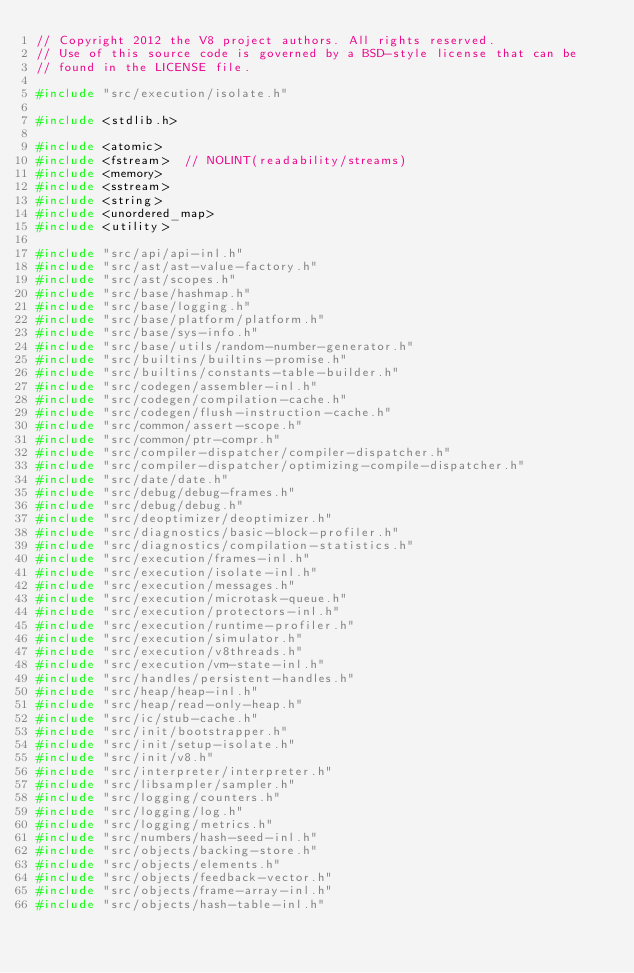<code> <loc_0><loc_0><loc_500><loc_500><_C++_>// Copyright 2012 the V8 project authors. All rights reserved.
// Use of this source code is governed by a BSD-style license that can be
// found in the LICENSE file.

#include "src/execution/isolate.h"

#include <stdlib.h>

#include <atomic>
#include <fstream>  // NOLINT(readability/streams)
#include <memory>
#include <sstream>
#include <string>
#include <unordered_map>
#include <utility>

#include "src/api/api-inl.h"
#include "src/ast/ast-value-factory.h"
#include "src/ast/scopes.h"
#include "src/base/hashmap.h"
#include "src/base/logging.h"
#include "src/base/platform/platform.h"
#include "src/base/sys-info.h"
#include "src/base/utils/random-number-generator.h"
#include "src/builtins/builtins-promise.h"
#include "src/builtins/constants-table-builder.h"
#include "src/codegen/assembler-inl.h"
#include "src/codegen/compilation-cache.h"
#include "src/codegen/flush-instruction-cache.h"
#include "src/common/assert-scope.h"
#include "src/common/ptr-compr.h"
#include "src/compiler-dispatcher/compiler-dispatcher.h"
#include "src/compiler-dispatcher/optimizing-compile-dispatcher.h"
#include "src/date/date.h"
#include "src/debug/debug-frames.h"
#include "src/debug/debug.h"
#include "src/deoptimizer/deoptimizer.h"
#include "src/diagnostics/basic-block-profiler.h"
#include "src/diagnostics/compilation-statistics.h"
#include "src/execution/frames-inl.h"
#include "src/execution/isolate-inl.h"
#include "src/execution/messages.h"
#include "src/execution/microtask-queue.h"
#include "src/execution/protectors-inl.h"
#include "src/execution/runtime-profiler.h"
#include "src/execution/simulator.h"
#include "src/execution/v8threads.h"
#include "src/execution/vm-state-inl.h"
#include "src/handles/persistent-handles.h"
#include "src/heap/heap-inl.h"
#include "src/heap/read-only-heap.h"
#include "src/ic/stub-cache.h"
#include "src/init/bootstrapper.h"
#include "src/init/setup-isolate.h"
#include "src/init/v8.h"
#include "src/interpreter/interpreter.h"
#include "src/libsampler/sampler.h"
#include "src/logging/counters.h"
#include "src/logging/log.h"
#include "src/logging/metrics.h"
#include "src/numbers/hash-seed-inl.h"
#include "src/objects/backing-store.h"
#include "src/objects/elements.h"
#include "src/objects/feedback-vector.h"
#include "src/objects/frame-array-inl.h"
#include "src/objects/hash-table-inl.h"</code> 